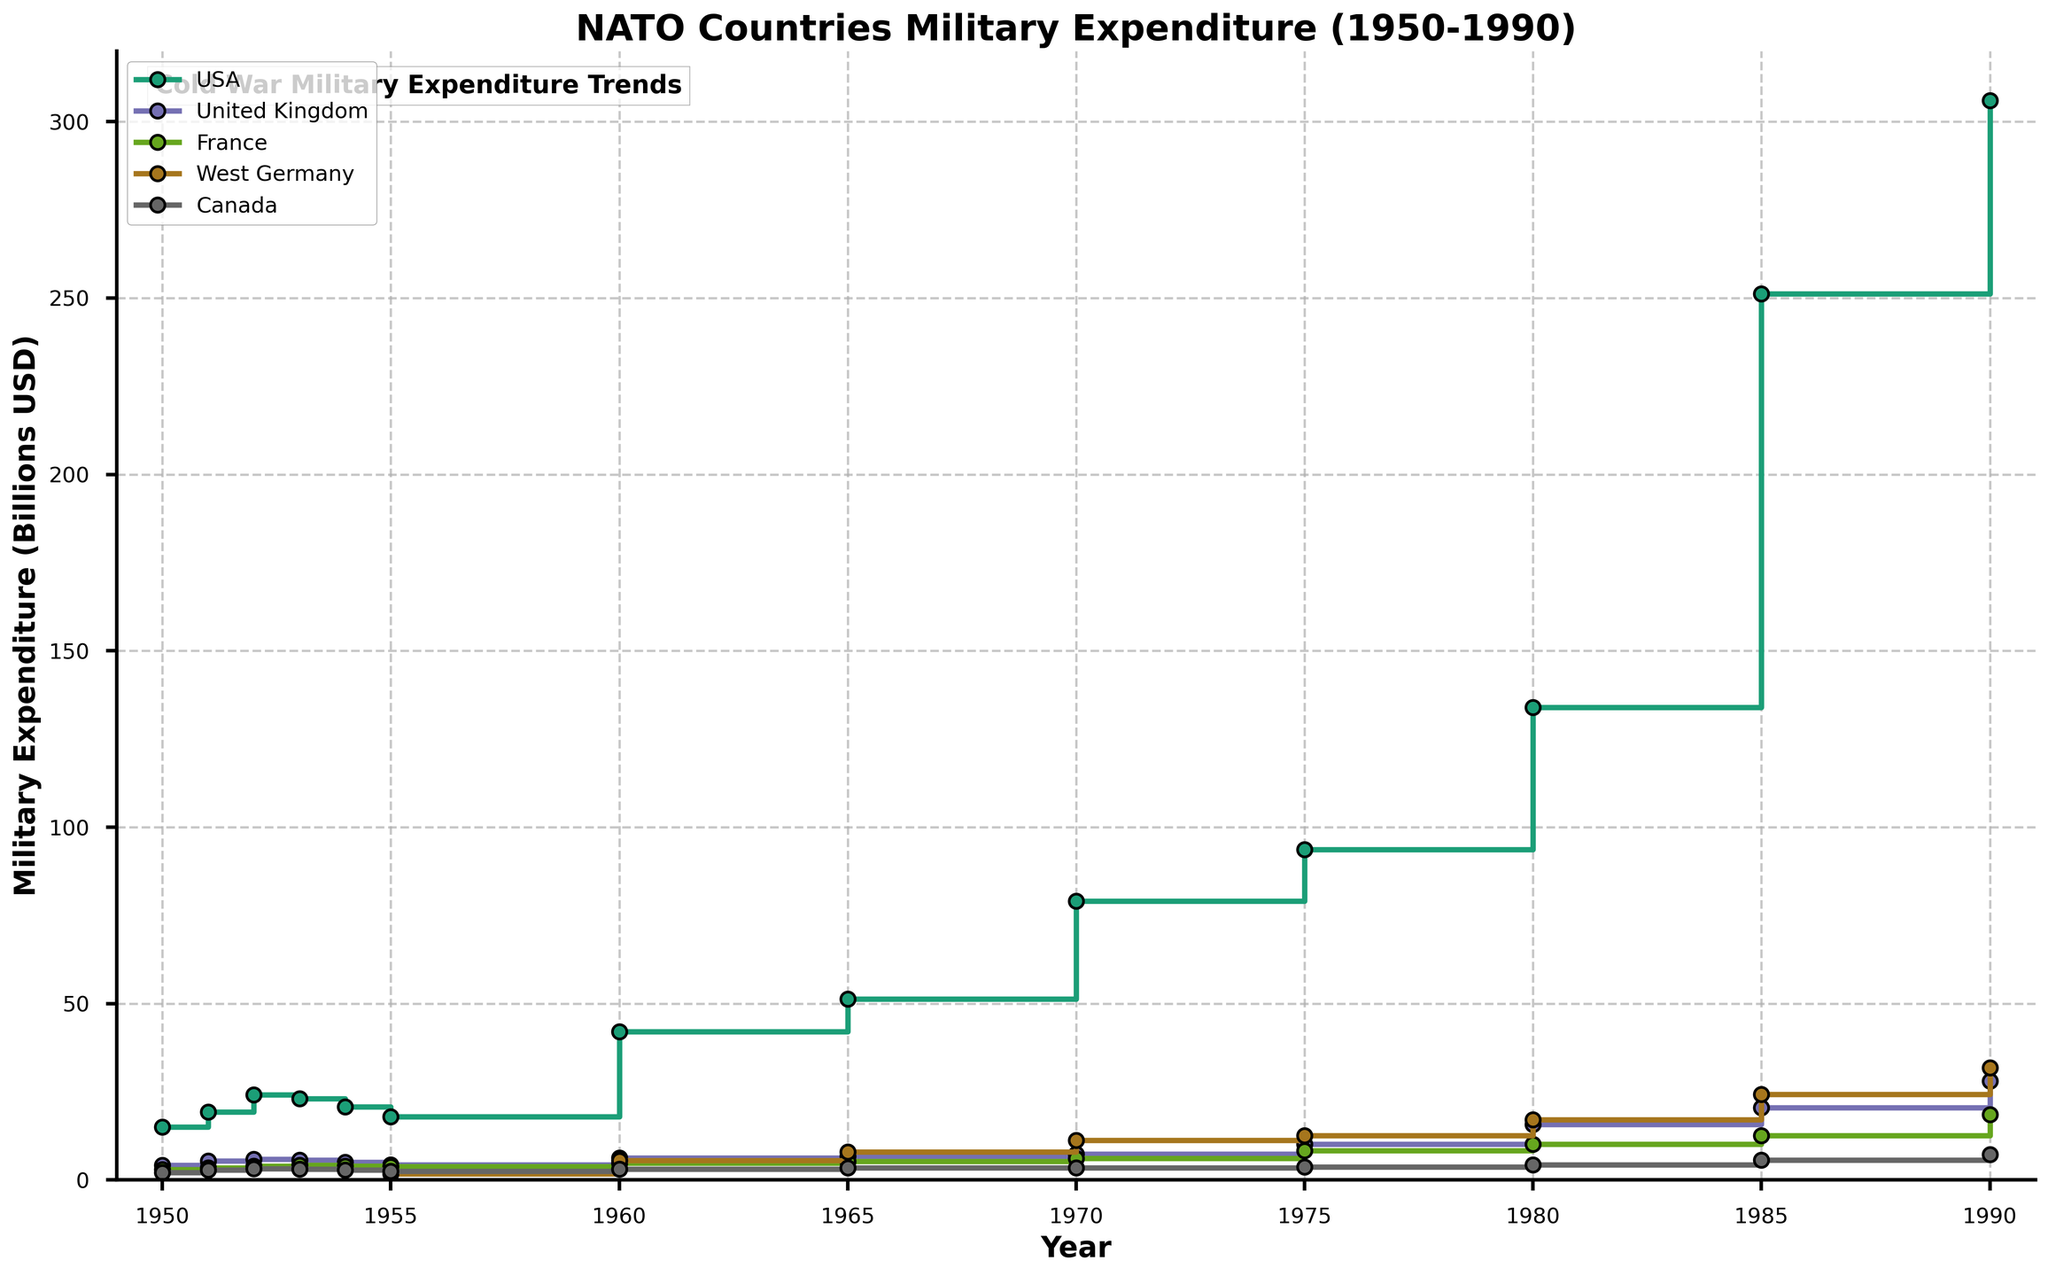What is the title of the figure? The title of the plot is prominently displayed at the top of the figure.
Answer: NATO Countries Military Expenditure (1950-1990) What is the unit of measurement on the y-axis? The y-axis label indicates the unit of measurement used in the figure.
Answer: Billions USD Which country had the highest military expenditure in 1990? The steps in the plot for each country in 1990 show the spending figures, allowing us to compare them. The USA's step is the highest.
Answer: USA What years are marked on the x-axis? The x-axis ticks are marked at certain intervals, representing the years included in the data.
Answer: 1950, 1955, 1960, 1965, 1970, 1975, 1980, 1985, 1990 How did the military expenditure of the USA change from 1980 to 1990? By observing the USA's steps on the plot, we note the values in 1980 and 1990 and compute the difference. The spending increased from $134 billion to $306 billion.
Answer: Increased by $172 billion Which country had the smallest increase in military expenditure between 1950 and 1990? By comparing the steps for each country from the start to the end years, we can calculate the change for each. Canada increased from $2.1 billion to $7.2 billion, the smallest change.
Answer: Canada What was the approximate military expenditure of France in 1975? By identifying the level of France's step in 1975 on the plot, we can read the spending value.
Answer: Approximately $8.3 billion How does the military expenditure trend for Canada compare to West Germany between 1960 and 1985? By comparing the steps of Canada and West Germany in 1960 and 1985, we can see that West Germany had a more significant increase in spending during this period.
Answer: West Germany increased more Which two countries had military expenditures most similar in 1980? By looking at the steps in 1980, we compare the values and find the closest ones for France ($10.1 billion) and Canada ($4.3 billion), which are not closest to each other, so an answer isn't straightforward. Closer ones are UK ($15.8 billion) to West Germany ($17.1 billion).
Answer: United Kingdom and West Germany What notable trend is observed in the USA's military expenditure over the entire period? Observing the USA's steps from 1950 to 1990, there is a pronounced upward trend indicating consistently increasing military expenditures with significant jumps like in 1980 to 1985.
Answer: Consistent upward trend 